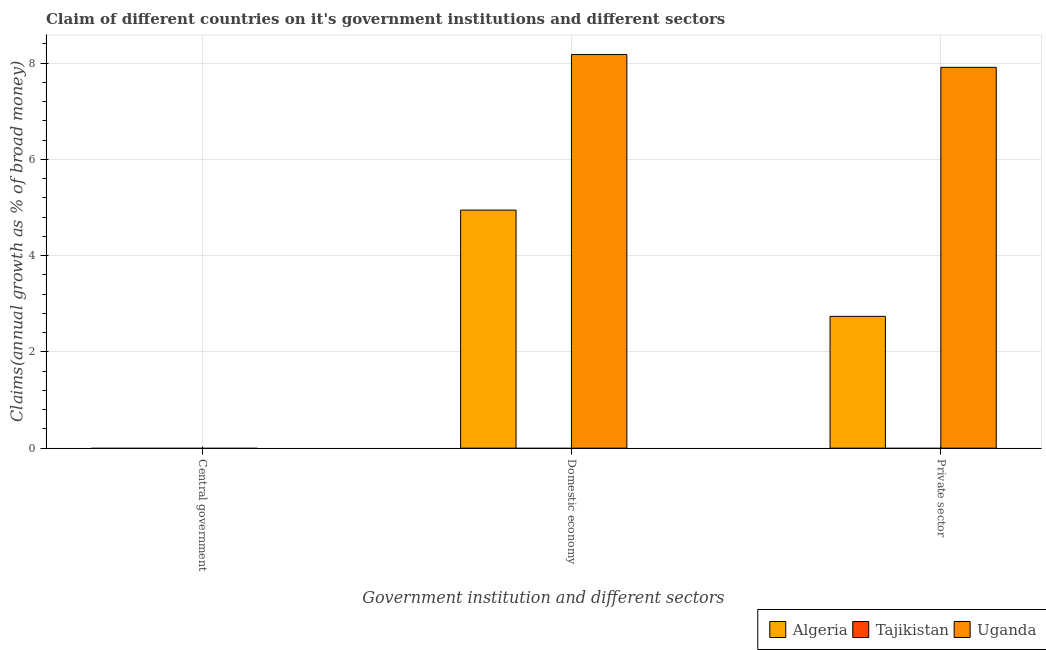Are the number of bars per tick equal to the number of legend labels?
Keep it short and to the point. No. What is the label of the 2nd group of bars from the left?
Provide a succinct answer. Domestic economy. Across all countries, what is the maximum percentage of claim on the domestic economy?
Offer a terse response. 8.18. In which country was the percentage of claim on the domestic economy maximum?
Your answer should be compact. Uganda. What is the total percentage of claim on the domestic economy in the graph?
Make the answer very short. 13.13. What is the difference between the percentage of claim on the domestic economy in Uganda and that in Algeria?
Ensure brevity in your answer.  3.23. What is the difference between the percentage of claim on the domestic economy in Tajikistan and the percentage of claim on the private sector in Uganda?
Your response must be concise. -7.91. What is the average percentage of claim on the private sector per country?
Make the answer very short. 3.55. What is the difference between the percentage of claim on the domestic economy and percentage of claim on the private sector in Uganda?
Your answer should be very brief. 0.27. In how many countries, is the percentage of claim on the domestic economy greater than 2 %?
Offer a very short reply. 2. What is the ratio of the percentage of claim on the domestic economy in Algeria to that in Uganda?
Keep it short and to the point. 0.6. Is the percentage of claim on the domestic economy in Algeria less than that in Uganda?
Give a very brief answer. Yes. Is the difference between the percentage of claim on the private sector in Uganda and Algeria greater than the difference between the percentage of claim on the domestic economy in Uganda and Algeria?
Your answer should be compact. Yes. What is the difference between the highest and the lowest percentage of claim on the private sector?
Ensure brevity in your answer.  7.91. In how many countries, is the percentage of claim on the domestic economy greater than the average percentage of claim on the domestic economy taken over all countries?
Make the answer very short. 2. Is it the case that in every country, the sum of the percentage of claim on the central government and percentage of claim on the domestic economy is greater than the percentage of claim on the private sector?
Offer a terse response. No. Are the values on the major ticks of Y-axis written in scientific E-notation?
Provide a succinct answer. No. Does the graph contain any zero values?
Your answer should be very brief. Yes. Where does the legend appear in the graph?
Keep it short and to the point. Bottom right. What is the title of the graph?
Keep it short and to the point. Claim of different countries on it's government institutions and different sectors. Does "Iran" appear as one of the legend labels in the graph?
Keep it short and to the point. No. What is the label or title of the X-axis?
Offer a very short reply. Government institution and different sectors. What is the label or title of the Y-axis?
Your answer should be compact. Claims(annual growth as % of broad money). What is the Claims(annual growth as % of broad money) in Algeria in Central government?
Your response must be concise. 0. What is the Claims(annual growth as % of broad money) of Tajikistan in Central government?
Provide a short and direct response. 0. What is the Claims(annual growth as % of broad money) in Algeria in Domestic economy?
Make the answer very short. 4.95. What is the Claims(annual growth as % of broad money) in Uganda in Domestic economy?
Give a very brief answer. 8.18. What is the Claims(annual growth as % of broad money) of Algeria in Private sector?
Give a very brief answer. 2.74. What is the Claims(annual growth as % of broad money) in Uganda in Private sector?
Your answer should be compact. 7.91. Across all Government institution and different sectors, what is the maximum Claims(annual growth as % of broad money) in Algeria?
Your response must be concise. 4.95. Across all Government institution and different sectors, what is the maximum Claims(annual growth as % of broad money) in Uganda?
Your response must be concise. 8.18. Across all Government institution and different sectors, what is the minimum Claims(annual growth as % of broad money) of Algeria?
Your answer should be compact. 0. Across all Government institution and different sectors, what is the minimum Claims(annual growth as % of broad money) in Uganda?
Your answer should be very brief. 0. What is the total Claims(annual growth as % of broad money) of Algeria in the graph?
Offer a terse response. 7.69. What is the total Claims(annual growth as % of broad money) of Uganda in the graph?
Your response must be concise. 16.1. What is the difference between the Claims(annual growth as % of broad money) in Algeria in Domestic economy and that in Private sector?
Your answer should be very brief. 2.21. What is the difference between the Claims(annual growth as % of broad money) of Uganda in Domestic economy and that in Private sector?
Provide a short and direct response. 0.27. What is the difference between the Claims(annual growth as % of broad money) of Algeria in Domestic economy and the Claims(annual growth as % of broad money) of Uganda in Private sector?
Offer a terse response. -2.97. What is the average Claims(annual growth as % of broad money) in Algeria per Government institution and different sectors?
Your response must be concise. 2.56. What is the average Claims(annual growth as % of broad money) of Tajikistan per Government institution and different sectors?
Provide a short and direct response. 0. What is the average Claims(annual growth as % of broad money) of Uganda per Government institution and different sectors?
Offer a terse response. 5.37. What is the difference between the Claims(annual growth as % of broad money) of Algeria and Claims(annual growth as % of broad money) of Uganda in Domestic economy?
Provide a succinct answer. -3.23. What is the difference between the Claims(annual growth as % of broad money) in Algeria and Claims(annual growth as % of broad money) in Uganda in Private sector?
Offer a very short reply. -5.17. What is the ratio of the Claims(annual growth as % of broad money) of Algeria in Domestic economy to that in Private sector?
Your response must be concise. 1.81. What is the ratio of the Claims(annual growth as % of broad money) in Uganda in Domestic economy to that in Private sector?
Your answer should be very brief. 1.03. What is the difference between the highest and the lowest Claims(annual growth as % of broad money) in Algeria?
Keep it short and to the point. 4.95. What is the difference between the highest and the lowest Claims(annual growth as % of broad money) in Uganda?
Offer a very short reply. 8.18. 